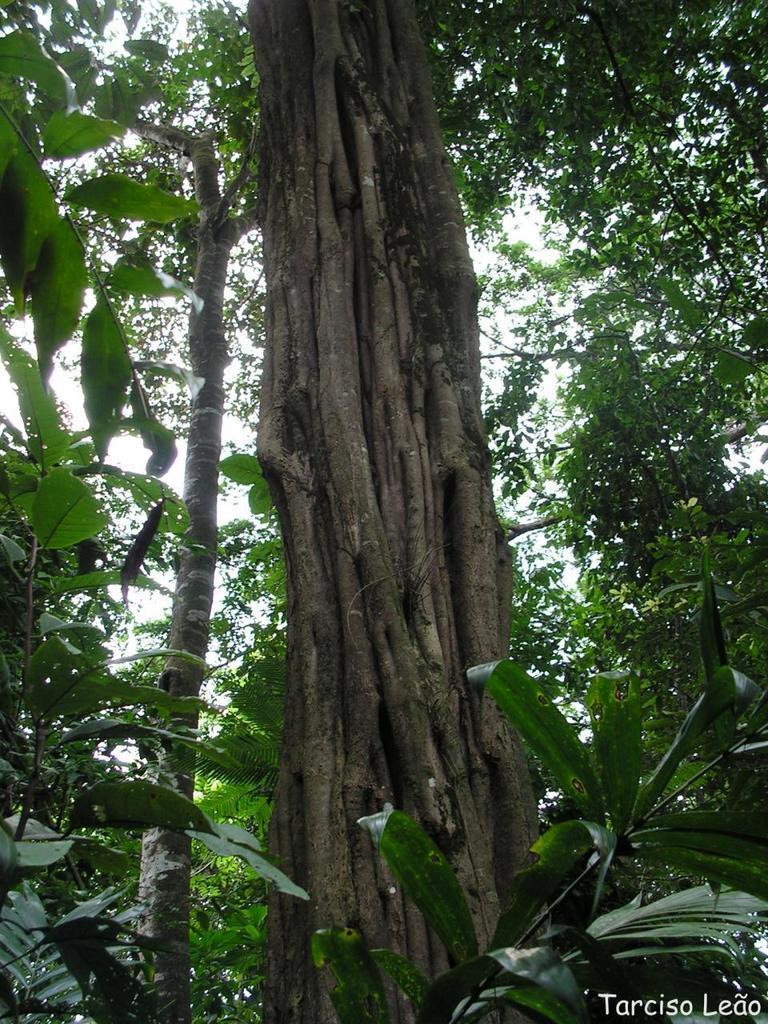Describe this image in one or two sentences. There is a tree trunk. Near to that there are trees. In the right bottom corner there is a watermark. 